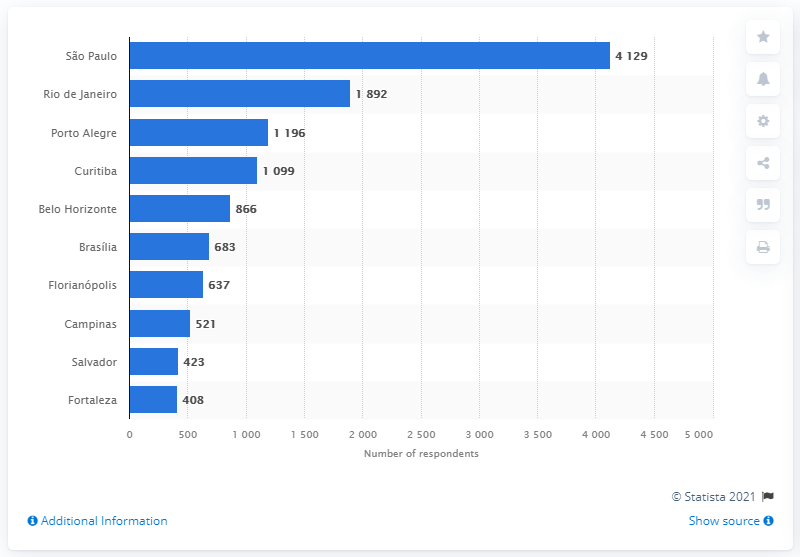Outline some significant characteristics in this image. Rio de Janeiro was the second largest vegetarian city in Brazil. 